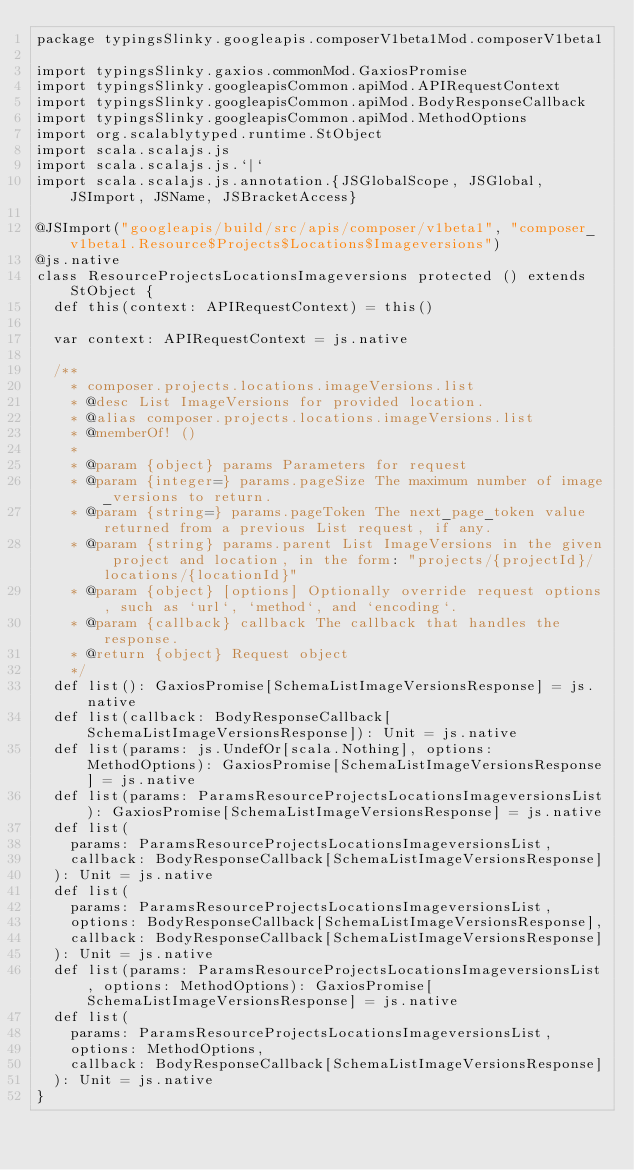<code> <loc_0><loc_0><loc_500><loc_500><_Scala_>package typingsSlinky.googleapis.composerV1beta1Mod.composerV1beta1

import typingsSlinky.gaxios.commonMod.GaxiosPromise
import typingsSlinky.googleapisCommon.apiMod.APIRequestContext
import typingsSlinky.googleapisCommon.apiMod.BodyResponseCallback
import typingsSlinky.googleapisCommon.apiMod.MethodOptions
import org.scalablytyped.runtime.StObject
import scala.scalajs.js
import scala.scalajs.js.`|`
import scala.scalajs.js.annotation.{JSGlobalScope, JSGlobal, JSImport, JSName, JSBracketAccess}

@JSImport("googleapis/build/src/apis/composer/v1beta1", "composer_v1beta1.Resource$Projects$Locations$Imageversions")
@js.native
class ResourceProjectsLocationsImageversions protected () extends StObject {
  def this(context: APIRequestContext) = this()
  
  var context: APIRequestContext = js.native
  
  /**
    * composer.projects.locations.imageVersions.list
    * @desc List ImageVersions for provided location.
    * @alias composer.projects.locations.imageVersions.list
    * @memberOf! ()
    *
    * @param {object} params Parameters for request
    * @param {integer=} params.pageSize The maximum number of image_versions to return.
    * @param {string=} params.pageToken The next_page_token value returned from a previous List request, if any.
    * @param {string} params.parent List ImageVersions in the given project and location, in the form: "projects/{projectId}/locations/{locationId}"
    * @param {object} [options] Optionally override request options, such as `url`, `method`, and `encoding`.
    * @param {callback} callback The callback that handles the response.
    * @return {object} Request object
    */
  def list(): GaxiosPromise[SchemaListImageVersionsResponse] = js.native
  def list(callback: BodyResponseCallback[SchemaListImageVersionsResponse]): Unit = js.native
  def list(params: js.UndefOr[scala.Nothing], options: MethodOptions): GaxiosPromise[SchemaListImageVersionsResponse] = js.native
  def list(params: ParamsResourceProjectsLocationsImageversionsList): GaxiosPromise[SchemaListImageVersionsResponse] = js.native
  def list(
    params: ParamsResourceProjectsLocationsImageversionsList,
    callback: BodyResponseCallback[SchemaListImageVersionsResponse]
  ): Unit = js.native
  def list(
    params: ParamsResourceProjectsLocationsImageversionsList,
    options: BodyResponseCallback[SchemaListImageVersionsResponse],
    callback: BodyResponseCallback[SchemaListImageVersionsResponse]
  ): Unit = js.native
  def list(params: ParamsResourceProjectsLocationsImageversionsList, options: MethodOptions): GaxiosPromise[SchemaListImageVersionsResponse] = js.native
  def list(
    params: ParamsResourceProjectsLocationsImageversionsList,
    options: MethodOptions,
    callback: BodyResponseCallback[SchemaListImageVersionsResponse]
  ): Unit = js.native
}
</code> 